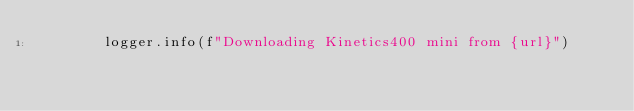Convert code to text. <code><loc_0><loc_0><loc_500><loc_500><_Python_>        logger.info(f"Downloading Kinetics400 mini from {url}")</code> 